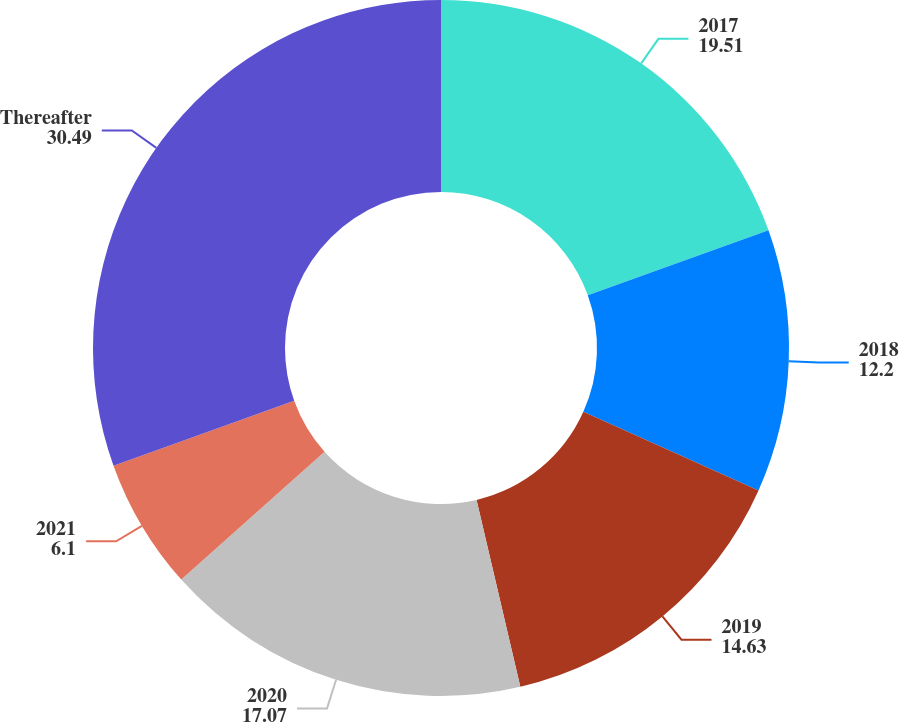Convert chart. <chart><loc_0><loc_0><loc_500><loc_500><pie_chart><fcel>2017<fcel>2018<fcel>2019<fcel>2020<fcel>2021<fcel>Thereafter<nl><fcel>19.51%<fcel>12.2%<fcel>14.63%<fcel>17.07%<fcel>6.1%<fcel>30.49%<nl></chart> 